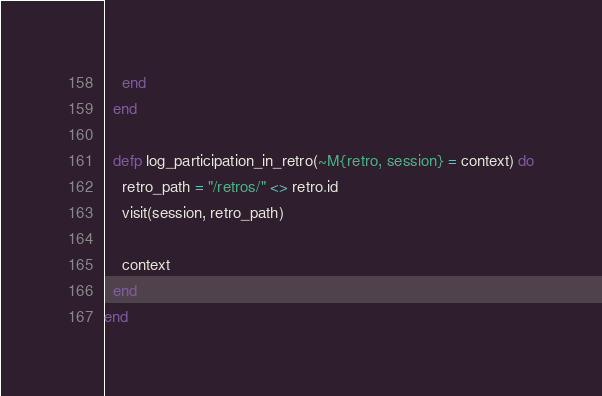<code> <loc_0><loc_0><loc_500><loc_500><_Elixir_>    end
  end

  defp log_participation_in_retro(~M{retro, session} = context) do
    retro_path = "/retros/" <> retro.id
    visit(session, retro_path)

    context
  end
end
</code> 